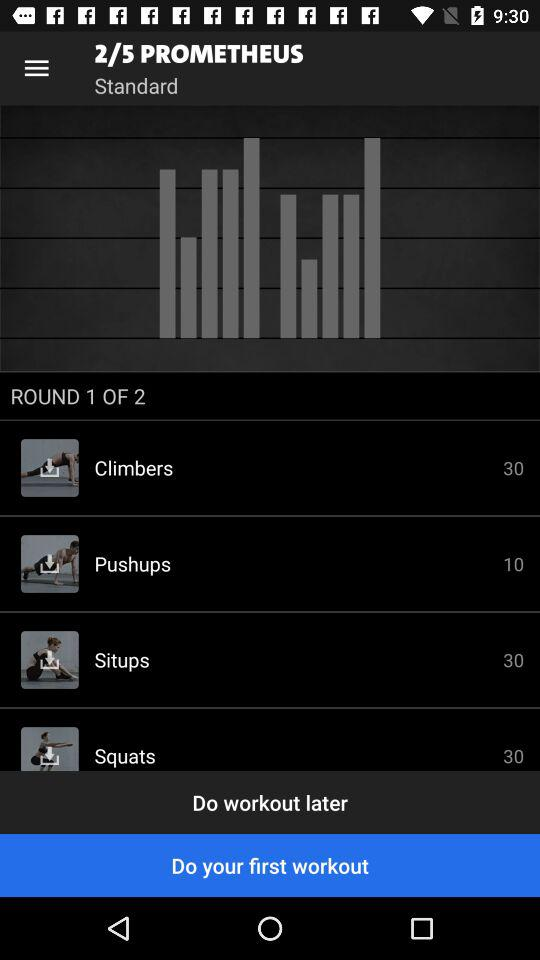Which exercise has a rep count of 10? The exercise is pushups. 